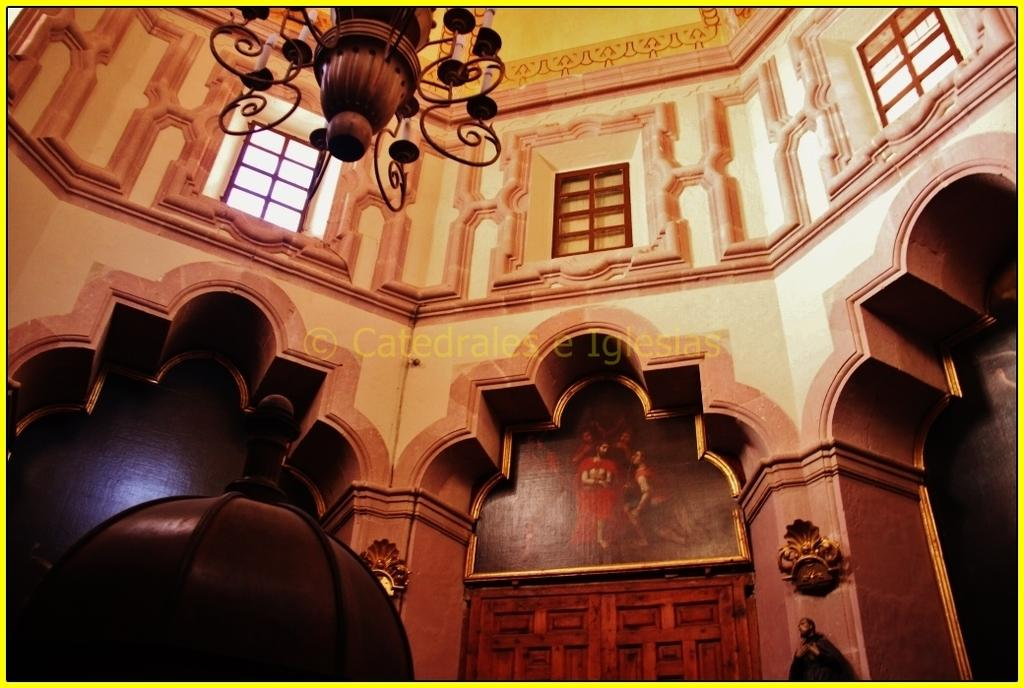Where was the image taken? The image was taken inside a building. What can be seen above a door in the image? There is a photograph above a door in the image. What type of lighting fixture is present in the ceiling of the image? There is a chandelier in the ceiling of the image. What architectural feature allows natural light to enter the building in the image? There are windows visible in the top part of the image. What type of farm equipment is visible in the image? There is no farm equipment present in the image; it was taken inside a building. What form of friction is being demonstrated in the image? There is no demonstration of friction in the image; it features a photograph, a chandelier, and windows. 